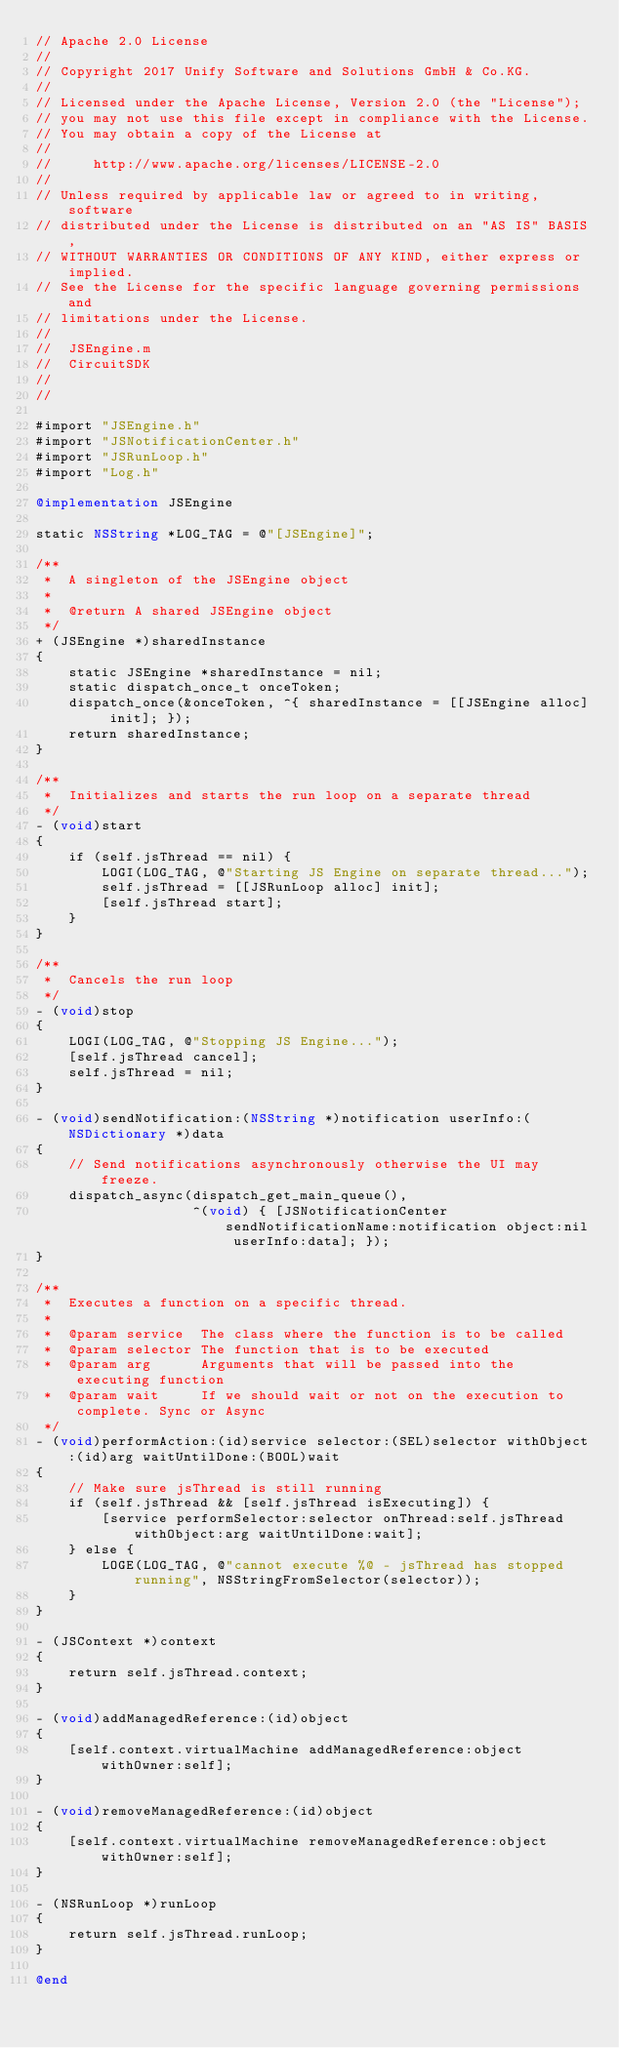Convert code to text. <code><loc_0><loc_0><loc_500><loc_500><_ObjectiveC_>// Apache 2.0 License
//
// Copyright 2017 Unify Software and Solutions GmbH & Co.KG.
//
// Licensed under the Apache License, Version 2.0 (the "License");
// you may not use this file except in compliance with the License.
// You may obtain a copy of the License at
//
//     http://www.apache.org/licenses/LICENSE-2.0
//
// Unless required by applicable law or agreed to in writing, software
// distributed under the License is distributed on an "AS IS" BASIS,
// WITHOUT WARRANTIES OR CONDITIONS OF ANY KIND, either express or implied.
// See the License for the specific language governing permissions and
// limitations under the License.
//
//  JSEngine.m
//  CircuitSDK
//
//

#import "JSEngine.h"
#import "JSNotificationCenter.h"
#import "JSRunLoop.h"
#import "Log.h"

@implementation JSEngine

static NSString *LOG_TAG = @"[JSEngine]";

/**
 *  A singleton of the JSEngine object
 *
 *  @return A shared JSEngine object
 */
+ (JSEngine *)sharedInstance
{
    static JSEngine *sharedInstance = nil;
    static dispatch_once_t onceToken;
    dispatch_once(&onceToken, ^{ sharedInstance = [[JSEngine alloc] init]; });
    return sharedInstance;
}

/**
 *  Initializes and starts the run loop on a separate thread
 */
- (void)start
{
    if (self.jsThread == nil) {
        LOGI(LOG_TAG, @"Starting JS Engine on separate thread...");
        self.jsThread = [[JSRunLoop alloc] init];
        [self.jsThread start];
    }
}

/**
 *  Cancels the run loop
 */
- (void)stop
{
    LOGI(LOG_TAG, @"Stopping JS Engine...");
    [self.jsThread cancel];
    self.jsThread = nil;
}

- (void)sendNotification:(NSString *)notification userInfo:(NSDictionary *)data
{
    // Send notifications asynchronously otherwise the UI may freeze.
    dispatch_async(dispatch_get_main_queue(),
                   ^(void) { [JSNotificationCenter sendNotificationName:notification object:nil userInfo:data]; });
}

/**
 *  Executes a function on a specific thread.
 *
 *  @param service  The class where the function is to be called
 *  @param selector The function that is to be executed
 *  @param arg      Arguments that will be passed into the executing function
 *  @param wait     If we should wait or not on the execution to complete. Sync or Async
 */
- (void)performAction:(id)service selector:(SEL)selector withObject:(id)arg waitUntilDone:(BOOL)wait
{
    // Make sure jsThread is still running
    if (self.jsThread && [self.jsThread isExecuting]) {
        [service performSelector:selector onThread:self.jsThread withObject:arg waitUntilDone:wait];
    } else {
        LOGE(LOG_TAG, @"cannot execute %@ - jsThread has stopped running", NSStringFromSelector(selector));
    }
}

- (JSContext *)context
{
    return self.jsThread.context;
}

- (void)addManagedReference:(id)object
{
    [self.context.virtualMachine addManagedReference:object withOwner:self];
}

- (void)removeManagedReference:(id)object
{
    [self.context.virtualMachine removeManagedReference:object withOwner:self];
}

- (NSRunLoop *)runLoop
{
    return self.jsThread.runLoop;
}

@end
</code> 